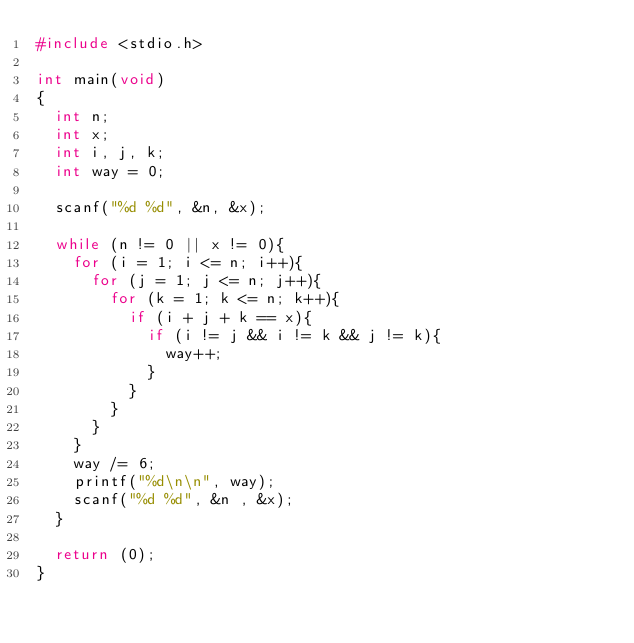Convert code to text. <code><loc_0><loc_0><loc_500><loc_500><_C_>#include <stdio.h>

int main(void)
{
	int n;
	int x;
	int i, j, k;
	int way = 0;
	
	scanf("%d %d", &n, &x);
	
	while (n != 0 || x != 0){
		for (i = 1; i <= n; i++){
			for (j = 1; j <= n; j++){
				for (k = 1; k <= n; k++){
					if (i + j + k == x){
						if (i != j && i != k && j != k){
							way++;
						}
					}
				}
			}
		}
		way /= 6;
		printf("%d\n\n", way);
		scanf("%d %d", &n , &x);
	}
	
	return (0);
}</code> 